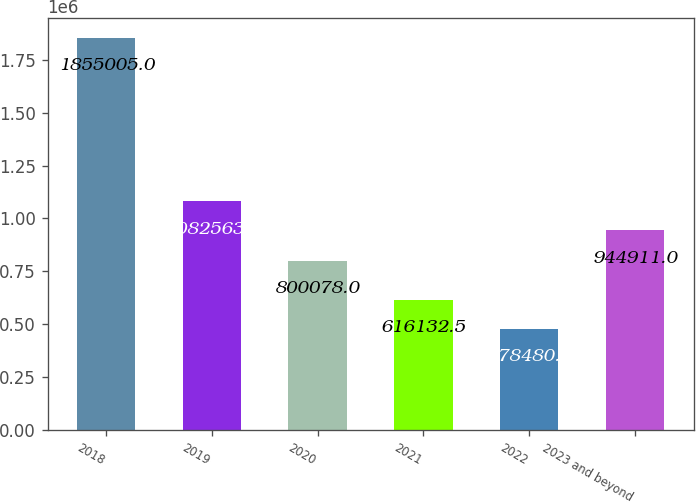Convert chart. <chart><loc_0><loc_0><loc_500><loc_500><bar_chart><fcel>2018<fcel>2019<fcel>2020<fcel>2021<fcel>2022<fcel>2023 and beyond<nl><fcel>1.855e+06<fcel>1.08256e+06<fcel>800078<fcel>616132<fcel>478480<fcel>944911<nl></chart> 